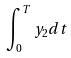Convert formula to latex. <formula><loc_0><loc_0><loc_500><loc_500>\int _ { 0 } ^ { T } y _ { 2 } d t</formula> 